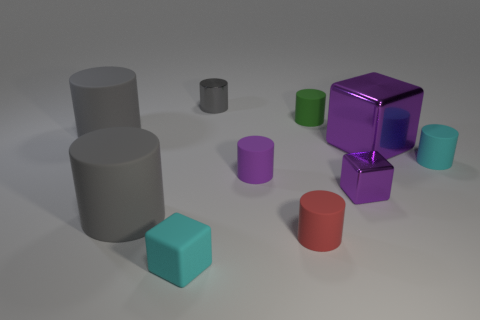Which of the objects in the image could roll if pushed? The objects that could roll if pushed include the cylinders - two large gray ones and one smaller red one. Their symmetrical round shapes allow them to rotate smoothly on an axis. 